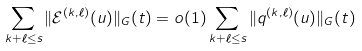<formula> <loc_0><loc_0><loc_500><loc_500>\sum _ { k + \ell \leq s } \| \mathcal { E } ^ { ( k , \ell ) } ( u ) \| _ { G } ( t ) = o ( 1 ) \sum _ { k + \ell \leq s } \| q ^ { ( k , \ell ) } ( u ) \| _ { G } ( t )</formula> 